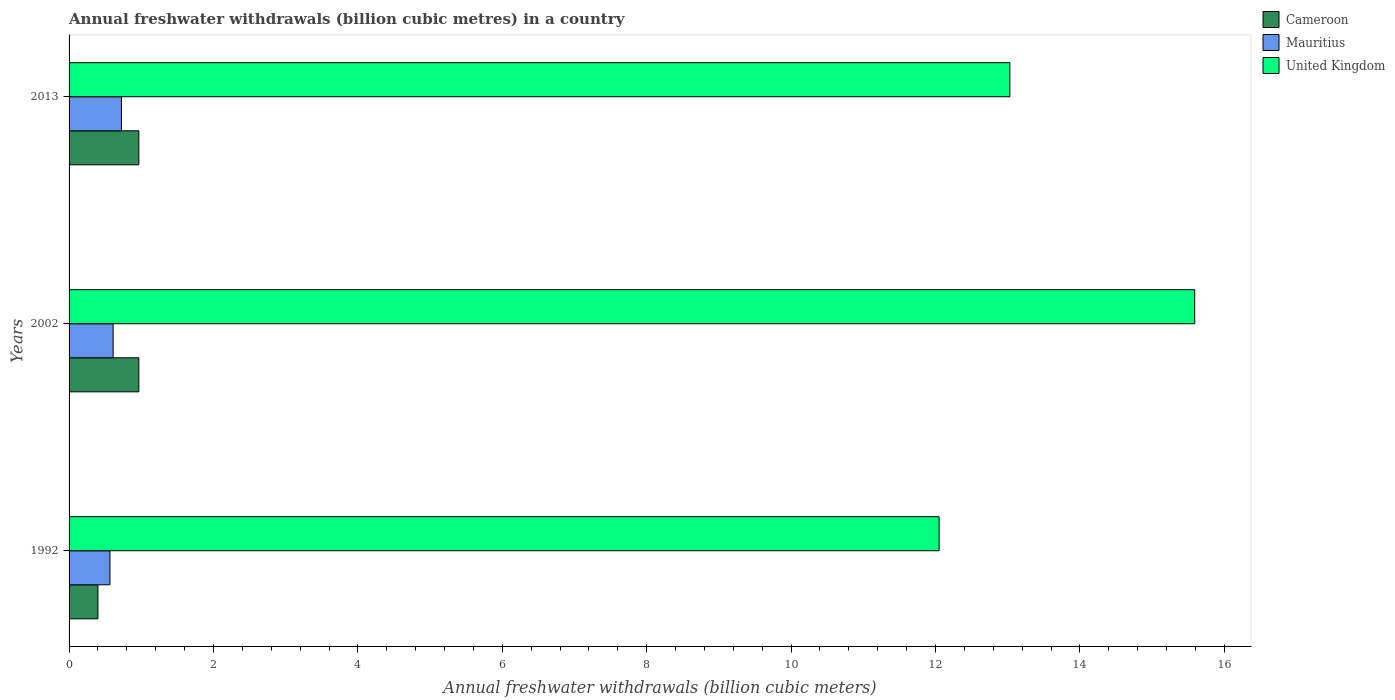How many bars are there on the 1st tick from the bottom?
Give a very brief answer. 3. What is the label of the 2nd group of bars from the top?
Offer a terse response. 2002. What is the annual freshwater withdrawals in Cameroon in 2002?
Ensure brevity in your answer.  0.97. Across all years, what is the maximum annual freshwater withdrawals in Mauritius?
Offer a very short reply. 0.72. Across all years, what is the minimum annual freshwater withdrawals in Mauritius?
Your answer should be very brief. 0.57. In which year was the annual freshwater withdrawals in United Kingdom minimum?
Your answer should be very brief. 1992. What is the total annual freshwater withdrawals in United Kingdom in the graph?
Offer a very short reply. 40.67. What is the difference between the annual freshwater withdrawals in Mauritius in 1992 and that in 2013?
Keep it short and to the point. -0.16. What is the difference between the annual freshwater withdrawals in Cameroon in 1992 and the annual freshwater withdrawals in United Kingdom in 2013?
Offer a terse response. -12.63. What is the average annual freshwater withdrawals in United Kingdom per year?
Ensure brevity in your answer.  13.56. In the year 1992, what is the difference between the annual freshwater withdrawals in Cameroon and annual freshwater withdrawals in United Kingdom?
Offer a terse response. -11.65. What is the ratio of the annual freshwater withdrawals in Cameroon in 2002 to that in 2013?
Offer a very short reply. 1. Is the difference between the annual freshwater withdrawals in Cameroon in 2002 and 2013 greater than the difference between the annual freshwater withdrawals in United Kingdom in 2002 and 2013?
Offer a very short reply. No. What is the difference between the highest and the lowest annual freshwater withdrawals in United Kingdom?
Offer a very short reply. 3.54. In how many years, is the annual freshwater withdrawals in Cameroon greater than the average annual freshwater withdrawals in Cameroon taken over all years?
Offer a terse response. 2. Is the sum of the annual freshwater withdrawals in Mauritius in 1992 and 2013 greater than the maximum annual freshwater withdrawals in United Kingdom across all years?
Offer a terse response. No. What does the 3rd bar from the top in 2002 represents?
Offer a very short reply. Cameroon. What does the 3rd bar from the bottom in 2013 represents?
Give a very brief answer. United Kingdom. Is it the case that in every year, the sum of the annual freshwater withdrawals in Mauritius and annual freshwater withdrawals in Cameroon is greater than the annual freshwater withdrawals in United Kingdom?
Ensure brevity in your answer.  No. Are all the bars in the graph horizontal?
Keep it short and to the point. Yes. What is the difference between two consecutive major ticks on the X-axis?
Your response must be concise. 2. Are the values on the major ticks of X-axis written in scientific E-notation?
Offer a terse response. No. Does the graph contain any zero values?
Your answer should be very brief. No. Does the graph contain grids?
Keep it short and to the point. No. Where does the legend appear in the graph?
Offer a very short reply. Top right. What is the title of the graph?
Provide a succinct answer. Annual freshwater withdrawals (billion cubic metres) in a country. Does "Algeria" appear as one of the legend labels in the graph?
Give a very brief answer. No. What is the label or title of the X-axis?
Your answer should be compact. Annual freshwater withdrawals (billion cubic meters). What is the Annual freshwater withdrawals (billion cubic meters) in Cameroon in 1992?
Keep it short and to the point. 0.4. What is the Annual freshwater withdrawals (billion cubic meters) of Mauritius in 1992?
Offer a terse response. 0.57. What is the Annual freshwater withdrawals (billion cubic meters) of United Kingdom in 1992?
Provide a short and direct response. 12.05. What is the Annual freshwater withdrawals (billion cubic meters) of Cameroon in 2002?
Offer a terse response. 0.97. What is the Annual freshwater withdrawals (billion cubic meters) of Mauritius in 2002?
Offer a very short reply. 0.61. What is the Annual freshwater withdrawals (billion cubic meters) in United Kingdom in 2002?
Provide a short and direct response. 15.59. What is the Annual freshwater withdrawals (billion cubic meters) in Cameroon in 2013?
Provide a short and direct response. 0.97. What is the Annual freshwater withdrawals (billion cubic meters) of Mauritius in 2013?
Keep it short and to the point. 0.72. What is the Annual freshwater withdrawals (billion cubic meters) of United Kingdom in 2013?
Your answer should be very brief. 13.03. Across all years, what is the maximum Annual freshwater withdrawals (billion cubic meters) of Cameroon?
Keep it short and to the point. 0.97. Across all years, what is the maximum Annual freshwater withdrawals (billion cubic meters) in Mauritius?
Offer a very short reply. 0.72. Across all years, what is the maximum Annual freshwater withdrawals (billion cubic meters) in United Kingdom?
Offer a terse response. 15.59. Across all years, what is the minimum Annual freshwater withdrawals (billion cubic meters) in Cameroon?
Provide a short and direct response. 0.4. Across all years, what is the minimum Annual freshwater withdrawals (billion cubic meters) in Mauritius?
Provide a succinct answer. 0.57. Across all years, what is the minimum Annual freshwater withdrawals (billion cubic meters) in United Kingdom?
Keep it short and to the point. 12.05. What is the total Annual freshwater withdrawals (billion cubic meters) in Cameroon in the graph?
Ensure brevity in your answer.  2.33. What is the total Annual freshwater withdrawals (billion cubic meters) of Mauritius in the graph?
Offer a terse response. 1.9. What is the total Annual freshwater withdrawals (billion cubic meters) in United Kingdom in the graph?
Offer a very short reply. 40.67. What is the difference between the Annual freshwater withdrawals (billion cubic meters) in Cameroon in 1992 and that in 2002?
Offer a terse response. -0.57. What is the difference between the Annual freshwater withdrawals (billion cubic meters) of Mauritius in 1992 and that in 2002?
Offer a terse response. -0.04. What is the difference between the Annual freshwater withdrawals (billion cubic meters) of United Kingdom in 1992 and that in 2002?
Your answer should be very brief. -3.54. What is the difference between the Annual freshwater withdrawals (billion cubic meters) in Cameroon in 1992 and that in 2013?
Provide a short and direct response. -0.57. What is the difference between the Annual freshwater withdrawals (billion cubic meters) in Mauritius in 1992 and that in 2013?
Your answer should be compact. -0.16. What is the difference between the Annual freshwater withdrawals (billion cubic meters) in United Kingdom in 1992 and that in 2013?
Your answer should be very brief. -0.98. What is the difference between the Annual freshwater withdrawals (billion cubic meters) in Mauritius in 2002 and that in 2013?
Give a very brief answer. -0.12. What is the difference between the Annual freshwater withdrawals (billion cubic meters) of United Kingdom in 2002 and that in 2013?
Your answer should be very brief. 2.56. What is the difference between the Annual freshwater withdrawals (billion cubic meters) of Cameroon in 1992 and the Annual freshwater withdrawals (billion cubic meters) of Mauritius in 2002?
Offer a very short reply. -0.21. What is the difference between the Annual freshwater withdrawals (billion cubic meters) in Cameroon in 1992 and the Annual freshwater withdrawals (billion cubic meters) in United Kingdom in 2002?
Your response must be concise. -15.19. What is the difference between the Annual freshwater withdrawals (billion cubic meters) in Mauritius in 1992 and the Annual freshwater withdrawals (billion cubic meters) in United Kingdom in 2002?
Make the answer very short. -15.02. What is the difference between the Annual freshwater withdrawals (billion cubic meters) in Cameroon in 1992 and the Annual freshwater withdrawals (billion cubic meters) in Mauritius in 2013?
Give a very brief answer. -0.33. What is the difference between the Annual freshwater withdrawals (billion cubic meters) of Cameroon in 1992 and the Annual freshwater withdrawals (billion cubic meters) of United Kingdom in 2013?
Provide a succinct answer. -12.63. What is the difference between the Annual freshwater withdrawals (billion cubic meters) of Mauritius in 1992 and the Annual freshwater withdrawals (billion cubic meters) of United Kingdom in 2013?
Ensure brevity in your answer.  -12.46. What is the difference between the Annual freshwater withdrawals (billion cubic meters) in Cameroon in 2002 and the Annual freshwater withdrawals (billion cubic meters) in Mauritius in 2013?
Ensure brevity in your answer.  0.24. What is the difference between the Annual freshwater withdrawals (billion cubic meters) of Cameroon in 2002 and the Annual freshwater withdrawals (billion cubic meters) of United Kingdom in 2013?
Ensure brevity in your answer.  -12.06. What is the difference between the Annual freshwater withdrawals (billion cubic meters) in Mauritius in 2002 and the Annual freshwater withdrawals (billion cubic meters) in United Kingdom in 2013?
Make the answer very short. -12.42. What is the average Annual freshwater withdrawals (billion cubic meters) in Cameroon per year?
Your answer should be compact. 0.78. What is the average Annual freshwater withdrawals (billion cubic meters) in Mauritius per year?
Ensure brevity in your answer.  0.63. What is the average Annual freshwater withdrawals (billion cubic meters) in United Kingdom per year?
Provide a short and direct response. 13.56. In the year 1992, what is the difference between the Annual freshwater withdrawals (billion cubic meters) of Cameroon and Annual freshwater withdrawals (billion cubic meters) of Mauritius?
Offer a very short reply. -0.17. In the year 1992, what is the difference between the Annual freshwater withdrawals (billion cubic meters) of Cameroon and Annual freshwater withdrawals (billion cubic meters) of United Kingdom?
Provide a succinct answer. -11.65. In the year 1992, what is the difference between the Annual freshwater withdrawals (billion cubic meters) in Mauritius and Annual freshwater withdrawals (billion cubic meters) in United Kingdom?
Offer a terse response. -11.48. In the year 2002, what is the difference between the Annual freshwater withdrawals (billion cubic meters) of Cameroon and Annual freshwater withdrawals (billion cubic meters) of Mauritius?
Ensure brevity in your answer.  0.36. In the year 2002, what is the difference between the Annual freshwater withdrawals (billion cubic meters) in Cameroon and Annual freshwater withdrawals (billion cubic meters) in United Kingdom?
Provide a succinct answer. -14.62. In the year 2002, what is the difference between the Annual freshwater withdrawals (billion cubic meters) of Mauritius and Annual freshwater withdrawals (billion cubic meters) of United Kingdom?
Your answer should be compact. -14.98. In the year 2013, what is the difference between the Annual freshwater withdrawals (billion cubic meters) of Cameroon and Annual freshwater withdrawals (billion cubic meters) of Mauritius?
Make the answer very short. 0.24. In the year 2013, what is the difference between the Annual freshwater withdrawals (billion cubic meters) in Cameroon and Annual freshwater withdrawals (billion cubic meters) in United Kingdom?
Offer a terse response. -12.06. In the year 2013, what is the difference between the Annual freshwater withdrawals (billion cubic meters) in Mauritius and Annual freshwater withdrawals (billion cubic meters) in United Kingdom?
Give a very brief answer. -12.3. What is the ratio of the Annual freshwater withdrawals (billion cubic meters) of Cameroon in 1992 to that in 2002?
Your answer should be compact. 0.41. What is the ratio of the Annual freshwater withdrawals (billion cubic meters) of Mauritius in 1992 to that in 2002?
Provide a succinct answer. 0.93. What is the ratio of the Annual freshwater withdrawals (billion cubic meters) in United Kingdom in 1992 to that in 2002?
Offer a very short reply. 0.77. What is the ratio of the Annual freshwater withdrawals (billion cubic meters) of Cameroon in 1992 to that in 2013?
Provide a short and direct response. 0.41. What is the ratio of the Annual freshwater withdrawals (billion cubic meters) in Mauritius in 1992 to that in 2013?
Your answer should be very brief. 0.78. What is the ratio of the Annual freshwater withdrawals (billion cubic meters) in United Kingdom in 1992 to that in 2013?
Give a very brief answer. 0.92. What is the ratio of the Annual freshwater withdrawals (billion cubic meters) of Cameroon in 2002 to that in 2013?
Give a very brief answer. 1. What is the ratio of the Annual freshwater withdrawals (billion cubic meters) of Mauritius in 2002 to that in 2013?
Your response must be concise. 0.84. What is the ratio of the Annual freshwater withdrawals (billion cubic meters) of United Kingdom in 2002 to that in 2013?
Ensure brevity in your answer.  1.2. What is the difference between the highest and the second highest Annual freshwater withdrawals (billion cubic meters) in Cameroon?
Offer a terse response. 0. What is the difference between the highest and the second highest Annual freshwater withdrawals (billion cubic meters) of Mauritius?
Offer a very short reply. 0.12. What is the difference between the highest and the second highest Annual freshwater withdrawals (billion cubic meters) in United Kingdom?
Offer a very short reply. 2.56. What is the difference between the highest and the lowest Annual freshwater withdrawals (billion cubic meters) of Cameroon?
Offer a terse response. 0.57. What is the difference between the highest and the lowest Annual freshwater withdrawals (billion cubic meters) of Mauritius?
Your answer should be compact. 0.16. What is the difference between the highest and the lowest Annual freshwater withdrawals (billion cubic meters) of United Kingdom?
Make the answer very short. 3.54. 